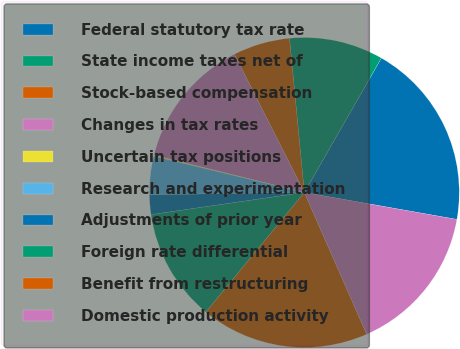<chart> <loc_0><loc_0><loc_500><loc_500><pie_chart><fcel>Federal statutory tax rate<fcel>State income taxes net of<fcel>Stock-based compensation<fcel>Changes in tax rates<fcel>Uncertain tax positions<fcel>Research and experimentation<fcel>Adjustments of prior year<fcel>Foreign rate differential<fcel>Benefit from restructuring<fcel>Domestic production activity<nl><fcel>19.5%<fcel>9.81%<fcel>5.93%<fcel>13.68%<fcel>0.11%<fcel>3.99%<fcel>2.05%<fcel>11.75%<fcel>17.56%<fcel>15.62%<nl></chart> 